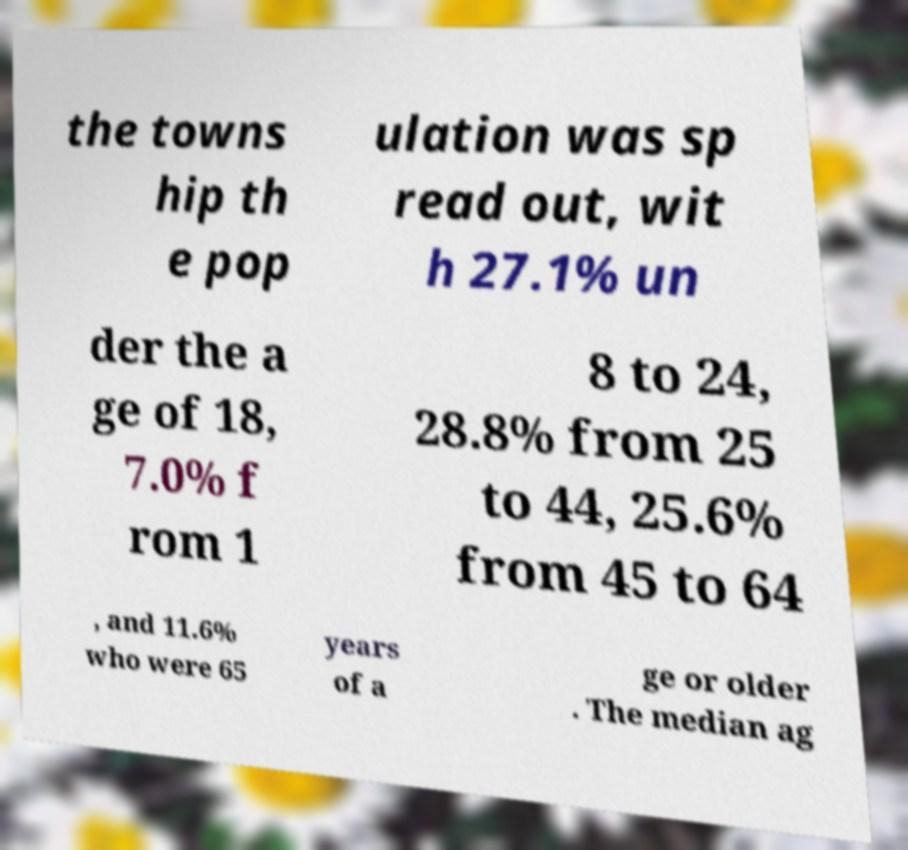For documentation purposes, I need the text within this image transcribed. Could you provide that? the towns hip th e pop ulation was sp read out, wit h 27.1% un der the a ge of 18, 7.0% f rom 1 8 to 24, 28.8% from 25 to 44, 25.6% from 45 to 64 , and 11.6% who were 65 years of a ge or older . The median ag 